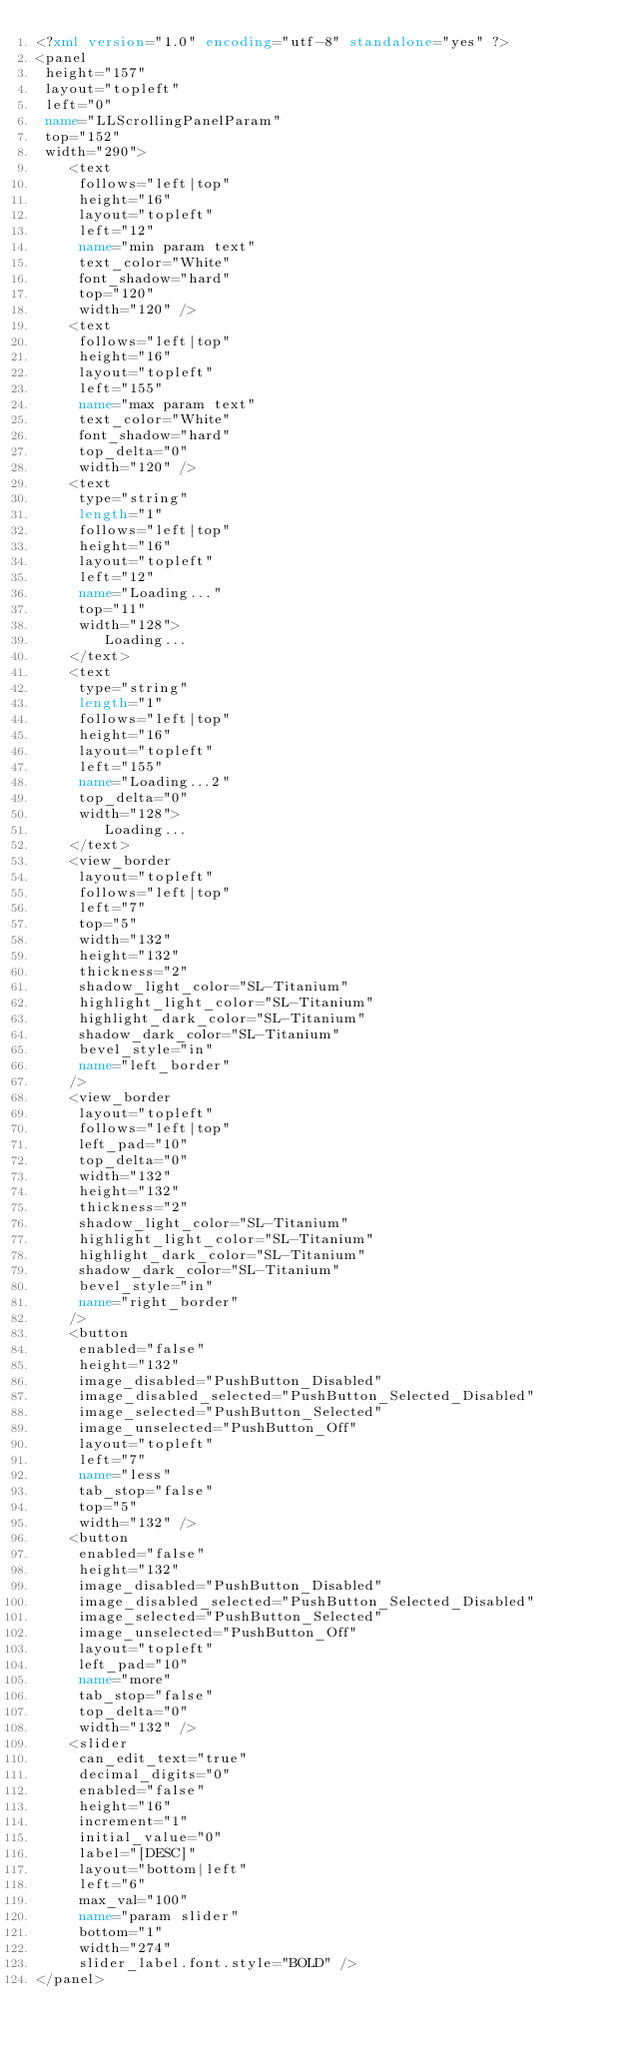<code> <loc_0><loc_0><loc_500><loc_500><_XML_><?xml version="1.0" encoding="utf-8" standalone="yes" ?>
<panel
 height="157"
 layout="topleft"
 left="0"
 name="LLScrollingPanelParam"
 top="152"
 width="290">
    <text
     follows="left|top"
     height="16"
     layout="topleft"
     left="12"
     name="min param text"
     text_color="White"
     font_shadow="hard"
     top="120"
     width="120" />
    <text
     follows="left|top"
     height="16"
     layout="topleft"
     left="155"
     name="max param text"
     text_color="White" 
     font_shadow="hard"
     top_delta="0"
     width="120" />
    <text
     type="string"
     length="1"
     follows="left|top"
     height="16"
     layout="topleft"
     left="12"
     name="Loading..."
     top="11"
     width="128">
        Loading...
    </text>
    <text
     type="string"
     length="1"
     follows="left|top"
     height="16"
     layout="topleft"
     left="155"
     name="Loading...2"
     top_delta="0"
     width="128">
        Loading...
    </text>
    <view_border 
     layout="topleft"
     follows="left|top"
     left="7"
     top="5"
     width="132"
     height="132"
     thickness="2"
     shadow_light_color="SL-Titanium"
     highlight_light_color="SL-Titanium"
     highlight_dark_color="SL-Titanium"
     shadow_dark_color="SL-Titanium"
     bevel_style="in"
     name="left_border"
    />
    <view_border 
     layout="topleft"
     follows="left|top"
     left_pad="10"
     top_delta="0"
     width="132"
     height="132"
     thickness="2"
     shadow_light_color="SL-Titanium"
     highlight_light_color="SL-Titanium"
     highlight_dark_color="SL-Titanium"
     shadow_dark_color="SL-Titanium"
     bevel_style="in"
     name="right_border"
    />
    <button
     enabled="false"
     height="132"
     image_disabled="PushButton_Disabled"
     image_disabled_selected="PushButton_Selected_Disabled"
     image_selected="PushButton_Selected"
     image_unselected="PushButton_Off"
     layout="topleft"
     left="7"
     name="less"
     tab_stop="false"
     top="5"
     width="132" />
    <button
     enabled="false"
     height="132"
     image_disabled="PushButton_Disabled"
     image_disabled_selected="PushButton_Selected_Disabled"
     image_selected="PushButton_Selected"
     image_unselected="PushButton_Off"
     layout="topleft"
     left_pad="10"
     name="more"
     tab_stop="false"
     top_delta="0"
     width="132" />
    <slider
     can_edit_text="true"
     decimal_digits="0"
     enabled="false"
     height="16"
     increment="1"
     initial_value="0"
     label="[DESC]"
     layout="bottom|left"
     left="6"
     max_val="100"
     name="param slider"
     bottom="1"
     width="274" 
     slider_label.font.style="BOLD" />
</panel>
</code> 